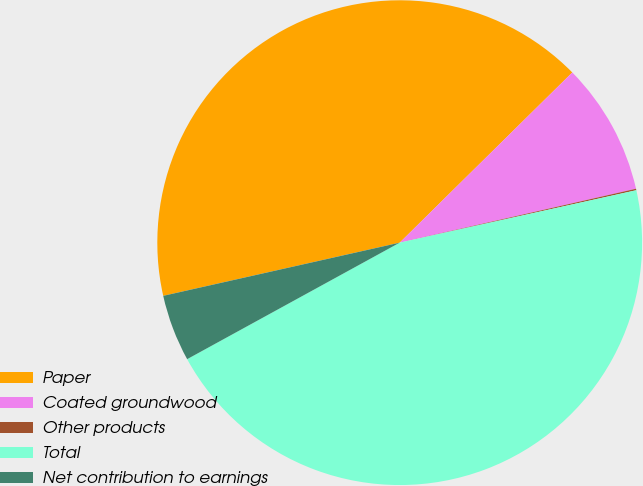<chart> <loc_0><loc_0><loc_500><loc_500><pie_chart><fcel>Paper<fcel>Coated groundwood<fcel>Other products<fcel>Total<fcel>Net contribution to earnings<nl><fcel>41.14%<fcel>8.82%<fcel>0.1%<fcel>45.5%<fcel>4.46%<nl></chart> 